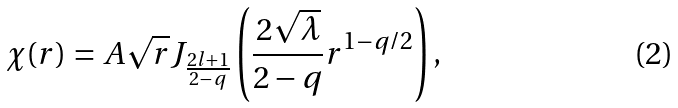Convert formula to latex. <formula><loc_0><loc_0><loc_500><loc_500>\chi ( r ) = A \sqrt { r } J _ { \frac { 2 l + 1 } { 2 - q } } \left ( \frac { 2 \sqrt { \lambda } } { 2 - q } r ^ { 1 - q / 2 } \right ) ,</formula> 